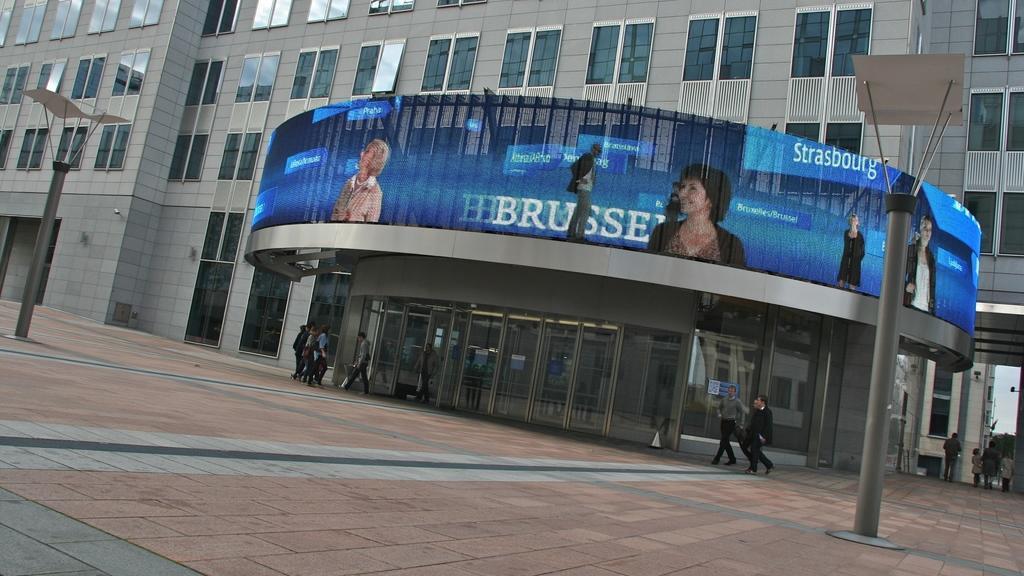Can you describe this image briefly? There is a building with windows. In front of the building there is a screen with images of people and something is written. Also there are doors. In front of the building there are many people, poles. 